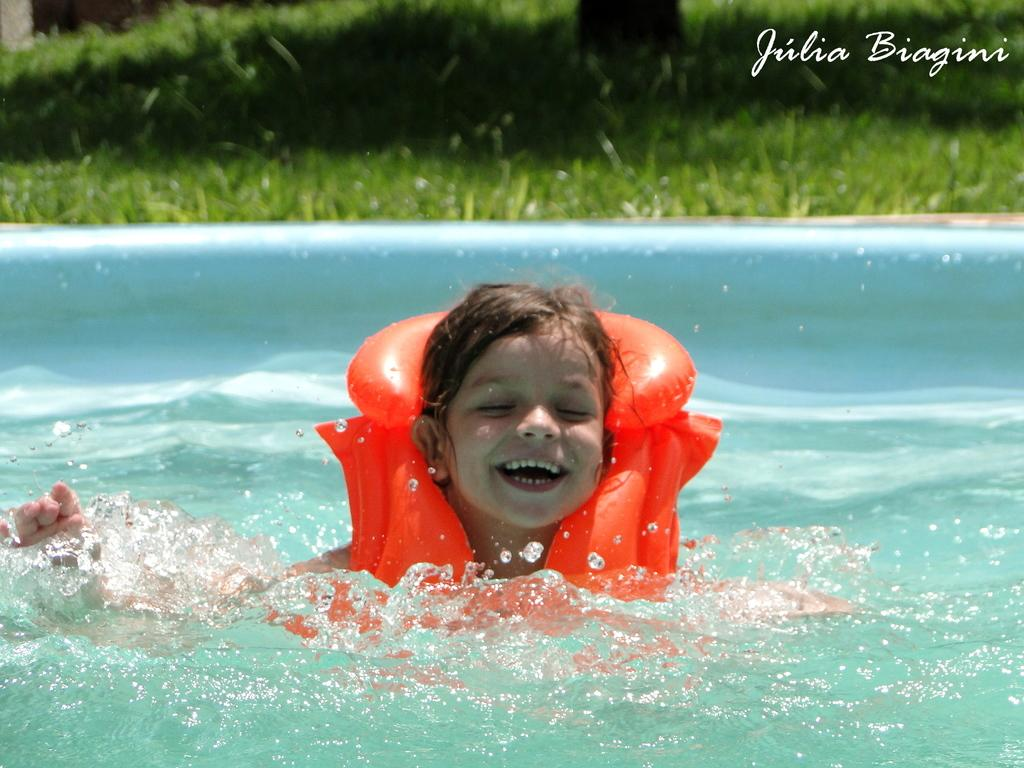Who is the main subject in the image? There is a girl in the image. What is the girl wearing? The girl is wearing a tube. What activity is the girl engaged in? The girl is swimming in a pool. What type of vegetation can be seen in the image? There is grass visible in the image. What is present in the top right corner of the image? There is some text in the top right corner of the image. What type of coil is visible in the image? There is no coil present in the image. What type of crib can be seen in the image? There is no crib present in the image. 